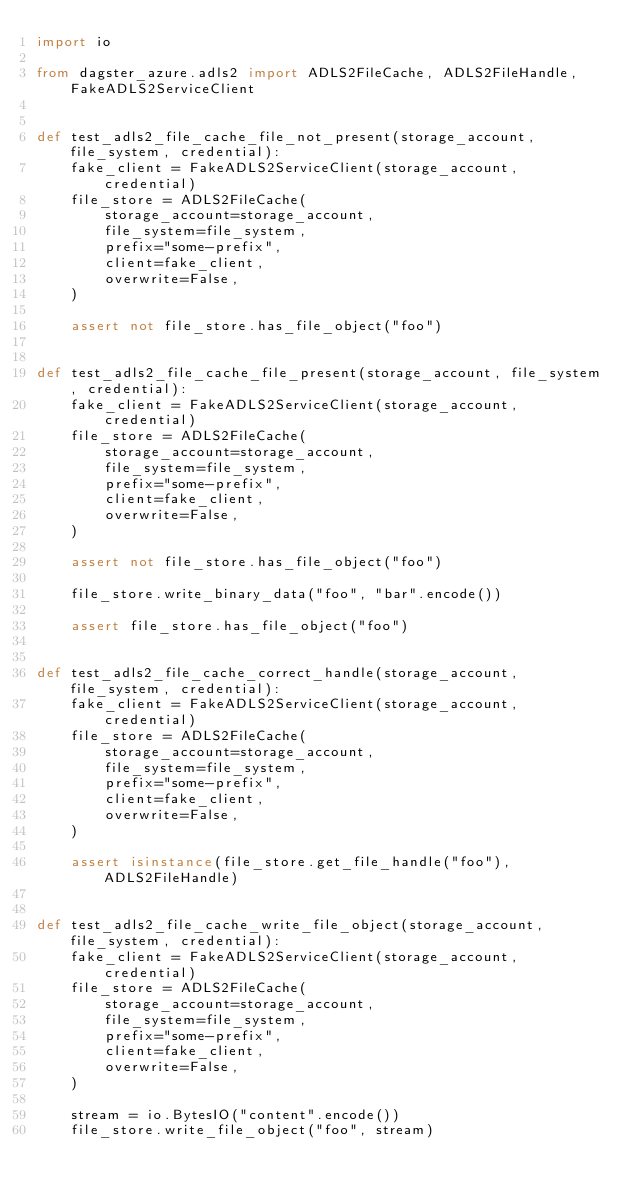<code> <loc_0><loc_0><loc_500><loc_500><_Python_>import io

from dagster_azure.adls2 import ADLS2FileCache, ADLS2FileHandle, FakeADLS2ServiceClient


def test_adls2_file_cache_file_not_present(storage_account, file_system, credential):
    fake_client = FakeADLS2ServiceClient(storage_account, credential)
    file_store = ADLS2FileCache(
        storage_account=storage_account,
        file_system=file_system,
        prefix="some-prefix",
        client=fake_client,
        overwrite=False,
    )

    assert not file_store.has_file_object("foo")


def test_adls2_file_cache_file_present(storage_account, file_system, credential):
    fake_client = FakeADLS2ServiceClient(storage_account, credential)
    file_store = ADLS2FileCache(
        storage_account=storage_account,
        file_system=file_system,
        prefix="some-prefix",
        client=fake_client,
        overwrite=False,
    )

    assert not file_store.has_file_object("foo")

    file_store.write_binary_data("foo", "bar".encode())

    assert file_store.has_file_object("foo")


def test_adls2_file_cache_correct_handle(storage_account, file_system, credential):
    fake_client = FakeADLS2ServiceClient(storage_account, credential)
    file_store = ADLS2FileCache(
        storage_account=storage_account,
        file_system=file_system,
        prefix="some-prefix",
        client=fake_client,
        overwrite=False,
    )

    assert isinstance(file_store.get_file_handle("foo"), ADLS2FileHandle)


def test_adls2_file_cache_write_file_object(storage_account, file_system, credential):
    fake_client = FakeADLS2ServiceClient(storage_account, credential)
    file_store = ADLS2FileCache(
        storage_account=storage_account,
        file_system=file_system,
        prefix="some-prefix",
        client=fake_client,
        overwrite=False,
    )

    stream = io.BytesIO("content".encode())
    file_store.write_file_object("foo", stream)
</code> 